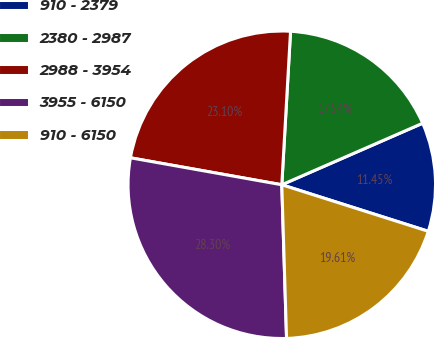Convert chart. <chart><loc_0><loc_0><loc_500><loc_500><pie_chart><fcel>910 - 2379<fcel>2380 - 2987<fcel>2988 - 3954<fcel>3955 - 6150<fcel>910 - 6150<nl><fcel>11.45%<fcel>17.54%<fcel>23.1%<fcel>28.3%<fcel>19.61%<nl></chart> 